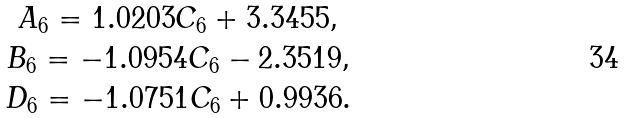<formula> <loc_0><loc_0><loc_500><loc_500>\begin{array} { c l l l c } A _ { 6 } = 1 . 0 2 0 3 C _ { 6 } + 3 . 3 4 5 5 , \\ B _ { 6 } = - 1 . 0 9 5 4 C _ { 6 } - 2 . 3 5 1 9 , \\ D _ { 6 } = - 1 . 0 7 5 1 C _ { 6 } + 0 . 9 9 3 6 . \end{array}</formula> 